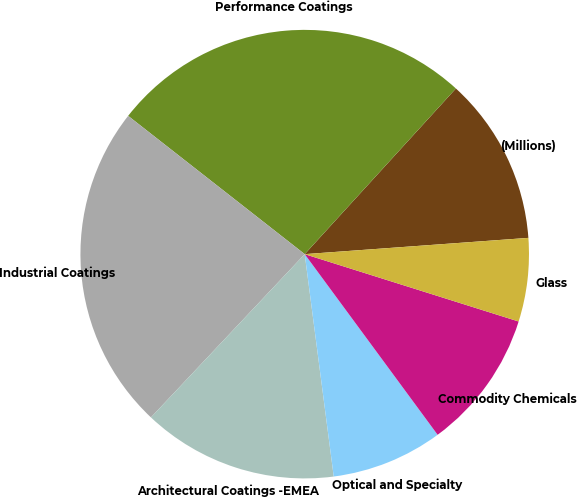<chart> <loc_0><loc_0><loc_500><loc_500><pie_chart><fcel>(Millions)<fcel>Performance Coatings<fcel>Industrial Coatings<fcel>Architectural Coatings -EMEA<fcel>Optical and Specialty<fcel>Commodity Chemicals<fcel>Glass<nl><fcel>12.07%<fcel>26.2%<fcel>23.55%<fcel>14.09%<fcel>8.03%<fcel>10.05%<fcel>6.01%<nl></chart> 